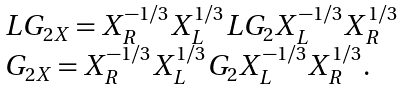Convert formula to latex. <formula><loc_0><loc_0><loc_500><loc_500>\begin{array} { l } { { L G _ { 2 X } = X _ { R } ^ { - 1 / 3 } X _ { L } ^ { 1 / 3 } L G _ { 2 } X _ { L } ^ { - 1 / 3 } X _ { R } ^ { 1 / 3 } } } \\ { { G _ { 2 X } = X _ { R } ^ { - 1 / 3 } X _ { L } ^ { 1 / 3 } G _ { 2 } X _ { L } ^ { - 1 / 3 } X _ { R } ^ { 1 / 3 } . } } \end{array}</formula> 